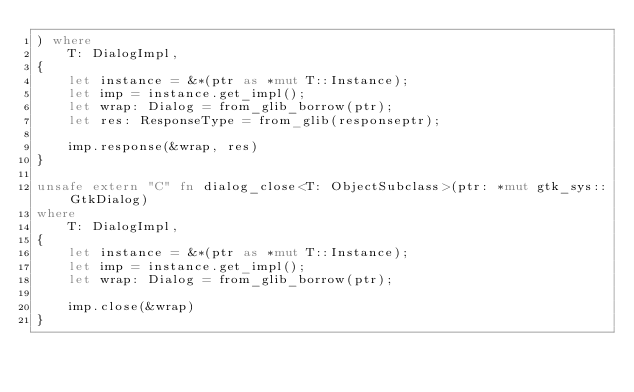<code> <loc_0><loc_0><loc_500><loc_500><_Rust_>) where
    T: DialogImpl,
{
    let instance = &*(ptr as *mut T::Instance);
    let imp = instance.get_impl();
    let wrap: Dialog = from_glib_borrow(ptr);
    let res: ResponseType = from_glib(responseptr);

    imp.response(&wrap, res)
}

unsafe extern "C" fn dialog_close<T: ObjectSubclass>(ptr: *mut gtk_sys::GtkDialog)
where
    T: DialogImpl,
{
    let instance = &*(ptr as *mut T::Instance);
    let imp = instance.get_impl();
    let wrap: Dialog = from_glib_borrow(ptr);

    imp.close(&wrap)
}
</code> 